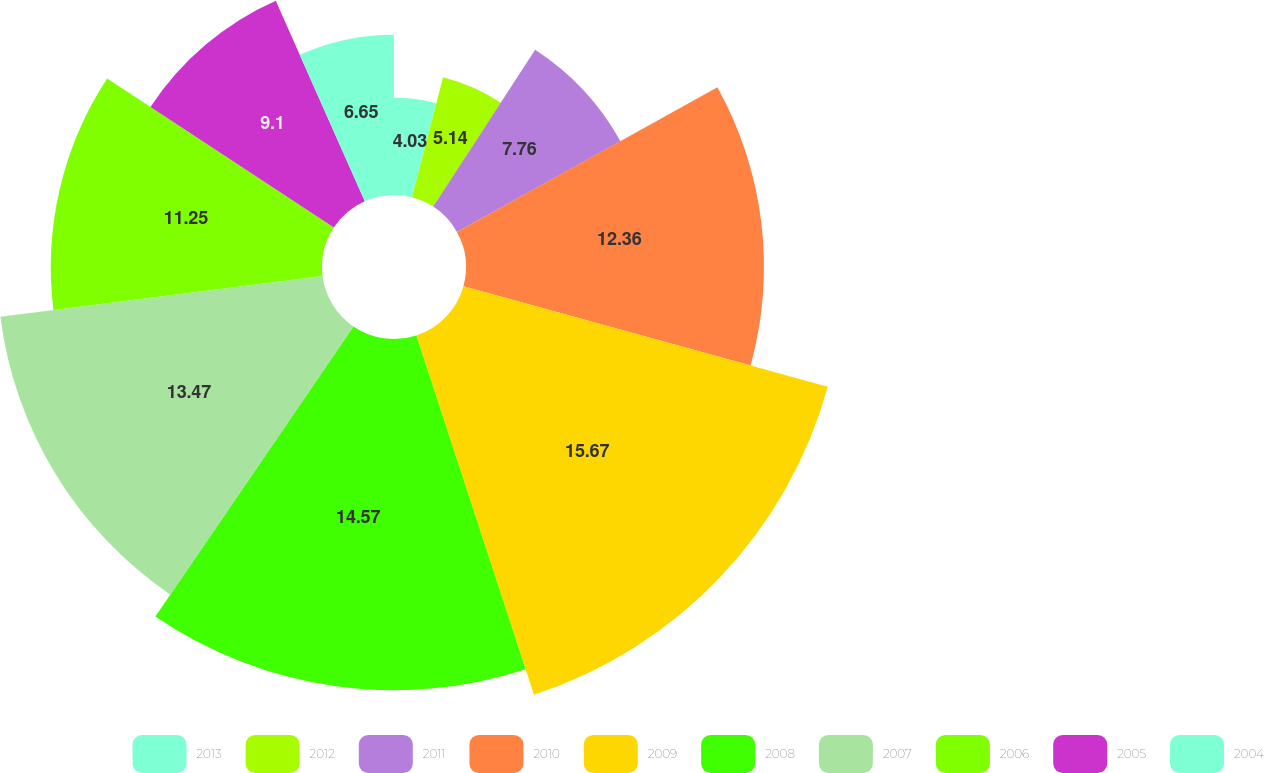<chart> <loc_0><loc_0><loc_500><loc_500><pie_chart><fcel>2013<fcel>2012<fcel>2011<fcel>2010<fcel>2009<fcel>2008<fcel>2007<fcel>2006<fcel>2005<fcel>2004<nl><fcel>4.03%<fcel>5.14%<fcel>7.76%<fcel>12.36%<fcel>15.68%<fcel>14.57%<fcel>13.47%<fcel>11.25%<fcel>9.1%<fcel>6.65%<nl></chart> 